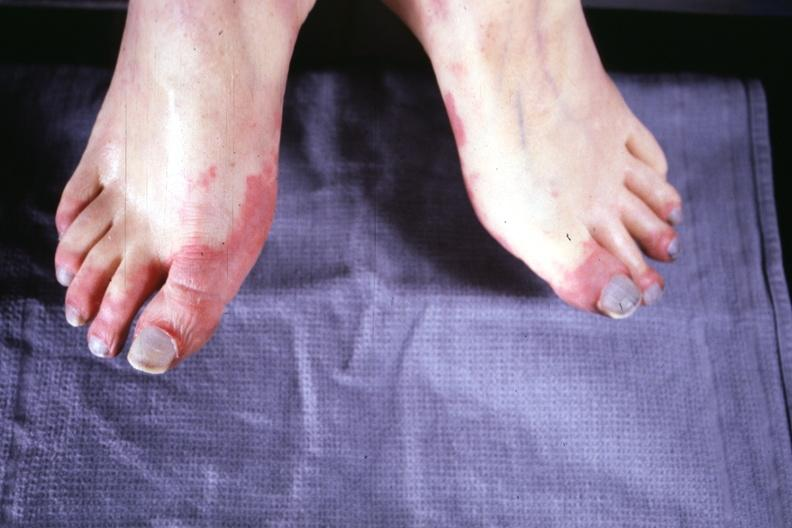what is present?
Answer the question using a single word or phrase. Gangrene 